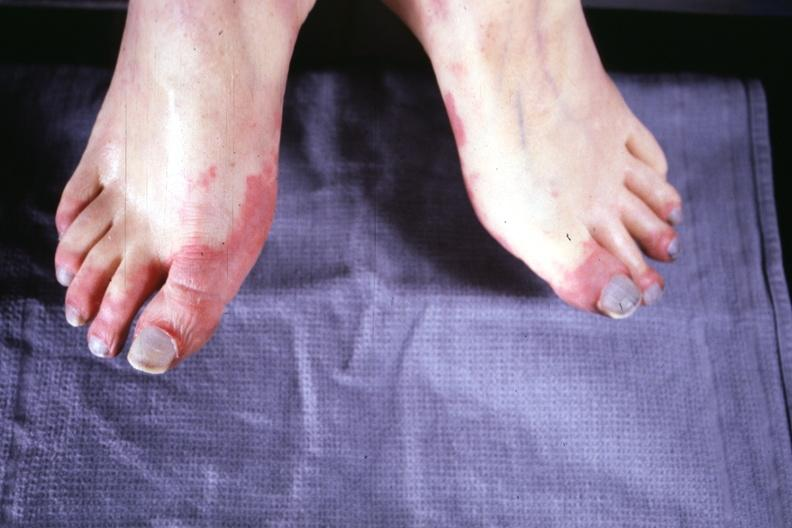what is present?
Answer the question using a single word or phrase. Gangrene 